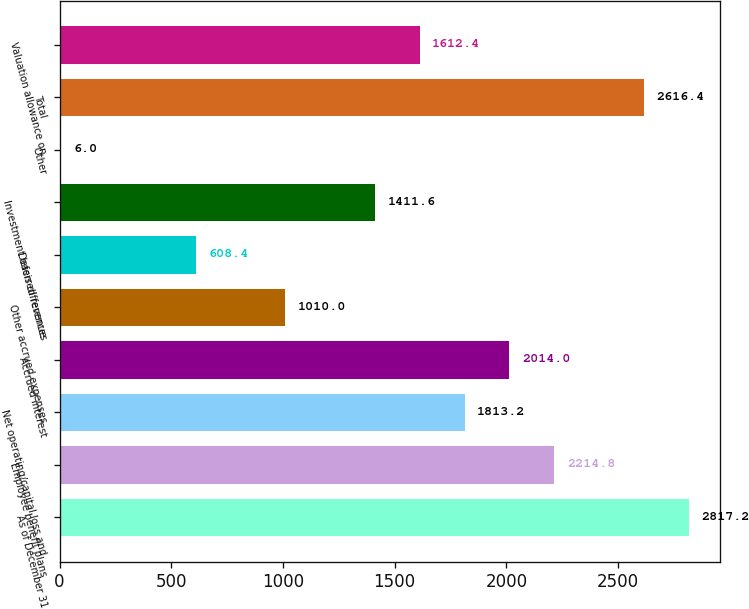Convert chart. <chart><loc_0><loc_0><loc_500><loc_500><bar_chart><fcel>As of December 31<fcel>Employee benefit plans<fcel>Net operating/capital loss and<fcel>Accrued interest<fcel>Other accrued expenses<fcel>Deferred revenue<fcel>Investment basis differences<fcel>Other<fcel>Total<fcel>Valuation allowance on<nl><fcel>2817.2<fcel>2214.8<fcel>1813.2<fcel>2014<fcel>1010<fcel>608.4<fcel>1411.6<fcel>6<fcel>2616.4<fcel>1612.4<nl></chart> 